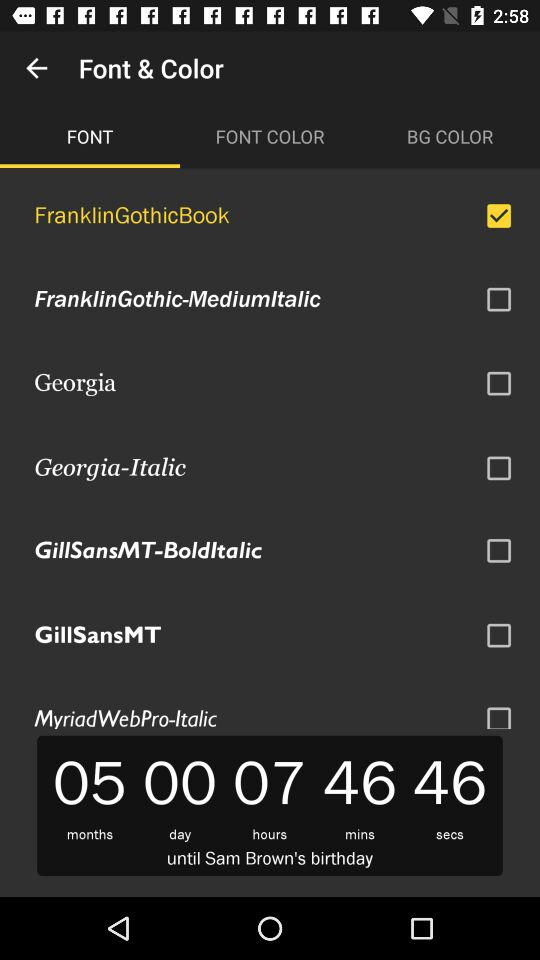What is the checked checkbox? The checked checkbox is "FranklinGothicBook". 